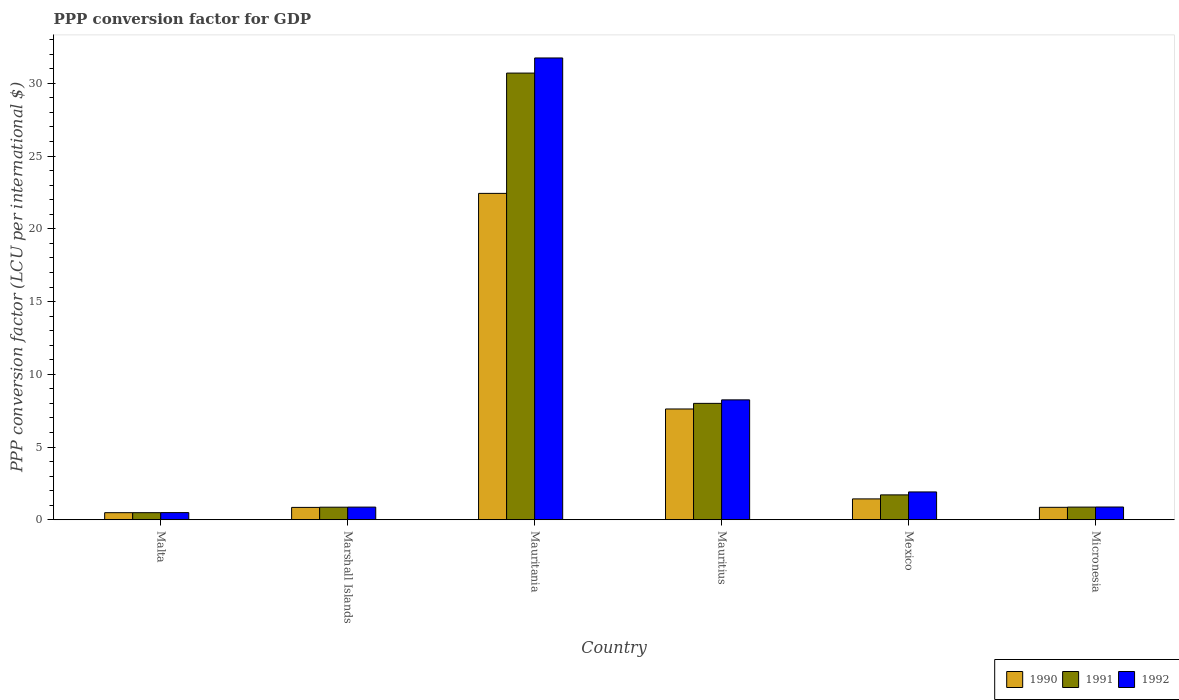How many different coloured bars are there?
Provide a short and direct response. 3. How many bars are there on the 3rd tick from the left?
Make the answer very short. 3. How many bars are there on the 5th tick from the right?
Your answer should be compact. 3. What is the label of the 4th group of bars from the left?
Your answer should be very brief. Mauritius. What is the PPP conversion factor for GDP in 1990 in Marshall Islands?
Make the answer very short. 0.85. Across all countries, what is the maximum PPP conversion factor for GDP in 1990?
Make the answer very short. 22.44. Across all countries, what is the minimum PPP conversion factor for GDP in 1992?
Your answer should be compact. 0.49. In which country was the PPP conversion factor for GDP in 1992 maximum?
Provide a short and direct response. Mauritania. In which country was the PPP conversion factor for GDP in 1990 minimum?
Provide a short and direct response. Malta. What is the total PPP conversion factor for GDP in 1990 in the graph?
Provide a succinct answer. 33.68. What is the difference between the PPP conversion factor for GDP in 1991 in Marshall Islands and that in Micronesia?
Your answer should be compact. -0.01. What is the difference between the PPP conversion factor for GDP in 1992 in Malta and the PPP conversion factor for GDP in 1990 in Marshall Islands?
Ensure brevity in your answer.  -0.36. What is the average PPP conversion factor for GDP in 1990 per country?
Your response must be concise. 5.61. What is the difference between the PPP conversion factor for GDP of/in 1991 and PPP conversion factor for GDP of/in 1990 in Mauritania?
Keep it short and to the point. 8.27. In how many countries, is the PPP conversion factor for GDP in 1991 greater than 6 LCU?
Your response must be concise. 2. What is the ratio of the PPP conversion factor for GDP in 1990 in Malta to that in Marshall Islands?
Your answer should be very brief. 0.57. Is the difference between the PPP conversion factor for GDP in 1991 in Malta and Marshall Islands greater than the difference between the PPP conversion factor for GDP in 1990 in Malta and Marshall Islands?
Offer a very short reply. No. What is the difference between the highest and the second highest PPP conversion factor for GDP in 1992?
Your answer should be compact. 6.33. What is the difference between the highest and the lowest PPP conversion factor for GDP in 1992?
Your response must be concise. 31.25. In how many countries, is the PPP conversion factor for GDP in 1991 greater than the average PPP conversion factor for GDP in 1991 taken over all countries?
Offer a terse response. 2. Is the sum of the PPP conversion factor for GDP in 1990 in Mexico and Micronesia greater than the maximum PPP conversion factor for GDP in 1991 across all countries?
Provide a succinct answer. No. What is the difference between two consecutive major ticks on the Y-axis?
Your answer should be compact. 5. Does the graph contain any zero values?
Ensure brevity in your answer.  No. How many legend labels are there?
Offer a terse response. 3. How are the legend labels stacked?
Your answer should be very brief. Horizontal. What is the title of the graph?
Provide a succinct answer. PPP conversion factor for GDP. Does "1994" appear as one of the legend labels in the graph?
Your answer should be compact. No. What is the label or title of the X-axis?
Provide a succinct answer. Country. What is the label or title of the Y-axis?
Keep it short and to the point. PPP conversion factor (LCU per international $). What is the PPP conversion factor (LCU per international $) of 1990 in Malta?
Provide a short and direct response. 0.49. What is the PPP conversion factor (LCU per international $) in 1991 in Malta?
Ensure brevity in your answer.  0.49. What is the PPP conversion factor (LCU per international $) in 1992 in Malta?
Make the answer very short. 0.49. What is the PPP conversion factor (LCU per international $) of 1990 in Marshall Islands?
Your answer should be compact. 0.85. What is the PPP conversion factor (LCU per international $) in 1991 in Marshall Islands?
Your response must be concise. 0.86. What is the PPP conversion factor (LCU per international $) of 1992 in Marshall Islands?
Offer a very short reply. 0.87. What is the PPP conversion factor (LCU per international $) of 1990 in Mauritania?
Keep it short and to the point. 22.44. What is the PPP conversion factor (LCU per international $) in 1991 in Mauritania?
Offer a terse response. 30.71. What is the PPP conversion factor (LCU per international $) of 1992 in Mauritania?
Provide a short and direct response. 31.75. What is the PPP conversion factor (LCU per international $) in 1990 in Mauritius?
Your answer should be compact. 7.62. What is the PPP conversion factor (LCU per international $) in 1991 in Mauritius?
Offer a very short reply. 8. What is the PPP conversion factor (LCU per international $) of 1992 in Mauritius?
Give a very brief answer. 8.24. What is the PPP conversion factor (LCU per international $) in 1990 in Mexico?
Your response must be concise. 1.43. What is the PPP conversion factor (LCU per international $) in 1991 in Mexico?
Your answer should be compact. 1.71. What is the PPP conversion factor (LCU per international $) of 1992 in Mexico?
Keep it short and to the point. 1.91. What is the PPP conversion factor (LCU per international $) of 1990 in Micronesia?
Provide a short and direct response. 0.86. What is the PPP conversion factor (LCU per international $) in 1991 in Micronesia?
Make the answer very short. 0.87. What is the PPP conversion factor (LCU per international $) of 1992 in Micronesia?
Your answer should be very brief. 0.88. Across all countries, what is the maximum PPP conversion factor (LCU per international $) of 1990?
Offer a terse response. 22.44. Across all countries, what is the maximum PPP conversion factor (LCU per international $) of 1991?
Provide a short and direct response. 30.71. Across all countries, what is the maximum PPP conversion factor (LCU per international $) in 1992?
Your response must be concise. 31.75. Across all countries, what is the minimum PPP conversion factor (LCU per international $) in 1990?
Provide a succinct answer. 0.49. Across all countries, what is the minimum PPP conversion factor (LCU per international $) in 1991?
Offer a very short reply. 0.49. Across all countries, what is the minimum PPP conversion factor (LCU per international $) in 1992?
Make the answer very short. 0.49. What is the total PPP conversion factor (LCU per international $) in 1990 in the graph?
Your response must be concise. 33.68. What is the total PPP conversion factor (LCU per international $) in 1991 in the graph?
Give a very brief answer. 42.64. What is the total PPP conversion factor (LCU per international $) of 1992 in the graph?
Your answer should be compact. 44.14. What is the difference between the PPP conversion factor (LCU per international $) of 1990 in Malta and that in Marshall Islands?
Provide a short and direct response. -0.36. What is the difference between the PPP conversion factor (LCU per international $) of 1991 in Malta and that in Marshall Islands?
Your response must be concise. -0.38. What is the difference between the PPP conversion factor (LCU per international $) of 1992 in Malta and that in Marshall Islands?
Offer a very short reply. -0.38. What is the difference between the PPP conversion factor (LCU per international $) in 1990 in Malta and that in Mauritania?
Your answer should be very brief. -21.95. What is the difference between the PPP conversion factor (LCU per international $) in 1991 in Malta and that in Mauritania?
Your response must be concise. -30.22. What is the difference between the PPP conversion factor (LCU per international $) of 1992 in Malta and that in Mauritania?
Keep it short and to the point. -31.25. What is the difference between the PPP conversion factor (LCU per international $) of 1990 in Malta and that in Mauritius?
Keep it short and to the point. -7.13. What is the difference between the PPP conversion factor (LCU per international $) of 1991 in Malta and that in Mauritius?
Your answer should be compact. -7.51. What is the difference between the PPP conversion factor (LCU per international $) in 1992 in Malta and that in Mauritius?
Your answer should be compact. -7.75. What is the difference between the PPP conversion factor (LCU per international $) of 1990 in Malta and that in Mexico?
Provide a short and direct response. -0.95. What is the difference between the PPP conversion factor (LCU per international $) in 1991 in Malta and that in Mexico?
Keep it short and to the point. -1.22. What is the difference between the PPP conversion factor (LCU per international $) in 1992 in Malta and that in Mexico?
Make the answer very short. -1.42. What is the difference between the PPP conversion factor (LCU per international $) in 1990 in Malta and that in Micronesia?
Make the answer very short. -0.37. What is the difference between the PPP conversion factor (LCU per international $) in 1991 in Malta and that in Micronesia?
Your answer should be very brief. -0.38. What is the difference between the PPP conversion factor (LCU per international $) in 1992 in Malta and that in Micronesia?
Offer a terse response. -0.38. What is the difference between the PPP conversion factor (LCU per international $) in 1990 in Marshall Islands and that in Mauritania?
Ensure brevity in your answer.  -21.59. What is the difference between the PPP conversion factor (LCU per international $) of 1991 in Marshall Islands and that in Mauritania?
Keep it short and to the point. -29.84. What is the difference between the PPP conversion factor (LCU per international $) in 1992 in Marshall Islands and that in Mauritania?
Your response must be concise. -30.88. What is the difference between the PPP conversion factor (LCU per international $) in 1990 in Marshall Islands and that in Mauritius?
Offer a terse response. -6.77. What is the difference between the PPP conversion factor (LCU per international $) in 1991 in Marshall Islands and that in Mauritius?
Offer a very short reply. -7.14. What is the difference between the PPP conversion factor (LCU per international $) of 1992 in Marshall Islands and that in Mauritius?
Offer a terse response. -7.37. What is the difference between the PPP conversion factor (LCU per international $) of 1990 in Marshall Islands and that in Mexico?
Provide a succinct answer. -0.58. What is the difference between the PPP conversion factor (LCU per international $) of 1991 in Marshall Islands and that in Mexico?
Your answer should be compact. -0.85. What is the difference between the PPP conversion factor (LCU per international $) in 1992 in Marshall Islands and that in Mexico?
Provide a succinct answer. -1.04. What is the difference between the PPP conversion factor (LCU per international $) in 1990 in Marshall Islands and that in Micronesia?
Your answer should be compact. -0.01. What is the difference between the PPP conversion factor (LCU per international $) of 1991 in Marshall Islands and that in Micronesia?
Keep it short and to the point. -0.01. What is the difference between the PPP conversion factor (LCU per international $) in 1992 in Marshall Islands and that in Micronesia?
Make the answer very short. -0.01. What is the difference between the PPP conversion factor (LCU per international $) of 1990 in Mauritania and that in Mauritius?
Make the answer very short. 14.82. What is the difference between the PPP conversion factor (LCU per international $) of 1991 in Mauritania and that in Mauritius?
Your response must be concise. 22.7. What is the difference between the PPP conversion factor (LCU per international $) of 1992 in Mauritania and that in Mauritius?
Give a very brief answer. 23.5. What is the difference between the PPP conversion factor (LCU per international $) of 1990 in Mauritania and that in Mexico?
Keep it short and to the point. 21. What is the difference between the PPP conversion factor (LCU per international $) in 1991 in Mauritania and that in Mexico?
Your response must be concise. 29. What is the difference between the PPP conversion factor (LCU per international $) in 1992 in Mauritania and that in Mexico?
Offer a very short reply. 29.83. What is the difference between the PPP conversion factor (LCU per international $) in 1990 in Mauritania and that in Micronesia?
Make the answer very short. 21.58. What is the difference between the PPP conversion factor (LCU per international $) of 1991 in Mauritania and that in Micronesia?
Give a very brief answer. 29.84. What is the difference between the PPP conversion factor (LCU per international $) in 1992 in Mauritania and that in Micronesia?
Make the answer very short. 30.87. What is the difference between the PPP conversion factor (LCU per international $) of 1990 in Mauritius and that in Mexico?
Your response must be concise. 6.18. What is the difference between the PPP conversion factor (LCU per international $) of 1991 in Mauritius and that in Mexico?
Provide a short and direct response. 6.29. What is the difference between the PPP conversion factor (LCU per international $) of 1992 in Mauritius and that in Mexico?
Give a very brief answer. 6.33. What is the difference between the PPP conversion factor (LCU per international $) in 1990 in Mauritius and that in Micronesia?
Your response must be concise. 6.76. What is the difference between the PPP conversion factor (LCU per international $) of 1991 in Mauritius and that in Micronesia?
Offer a very short reply. 7.13. What is the difference between the PPP conversion factor (LCU per international $) in 1992 in Mauritius and that in Micronesia?
Give a very brief answer. 7.37. What is the difference between the PPP conversion factor (LCU per international $) in 1990 in Mexico and that in Micronesia?
Ensure brevity in your answer.  0.58. What is the difference between the PPP conversion factor (LCU per international $) in 1991 in Mexico and that in Micronesia?
Provide a succinct answer. 0.84. What is the difference between the PPP conversion factor (LCU per international $) in 1992 in Mexico and that in Micronesia?
Offer a very short reply. 1.04. What is the difference between the PPP conversion factor (LCU per international $) in 1990 in Malta and the PPP conversion factor (LCU per international $) in 1991 in Marshall Islands?
Ensure brevity in your answer.  -0.38. What is the difference between the PPP conversion factor (LCU per international $) of 1990 in Malta and the PPP conversion factor (LCU per international $) of 1992 in Marshall Islands?
Ensure brevity in your answer.  -0.38. What is the difference between the PPP conversion factor (LCU per international $) in 1991 in Malta and the PPP conversion factor (LCU per international $) in 1992 in Marshall Islands?
Give a very brief answer. -0.38. What is the difference between the PPP conversion factor (LCU per international $) in 1990 in Malta and the PPP conversion factor (LCU per international $) in 1991 in Mauritania?
Your answer should be compact. -30.22. What is the difference between the PPP conversion factor (LCU per international $) in 1990 in Malta and the PPP conversion factor (LCU per international $) in 1992 in Mauritania?
Provide a succinct answer. -31.26. What is the difference between the PPP conversion factor (LCU per international $) in 1991 in Malta and the PPP conversion factor (LCU per international $) in 1992 in Mauritania?
Keep it short and to the point. -31.26. What is the difference between the PPP conversion factor (LCU per international $) of 1990 in Malta and the PPP conversion factor (LCU per international $) of 1991 in Mauritius?
Provide a short and direct response. -7.51. What is the difference between the PPP conversion factor (LCU per international $) of 1990 in Malta and the PPP conversion factor (LCU per international $) of 1992 in Mauritius?
Provide a succinct answer. -7.76. What is the difference between the PPP conversion factor (LCU per international $) of 1991 in Malta and the PPP conversion factor (LCU per international $) of 1992 in Mauritius?
Provide a short and direct response. -7.76. What is the difference between the PPP conversion factor (LCU per international $) in 1990 in Malta and the PPP conversion factor (LCU per international $) in 1991 in Mexico?
Make the answer very short. -1.22. What is the difference between the PPP conversion factor (LCU per international $) of 1990 in Malta and the PPP conversion factor (LCU per international $) of 1992 in Mexico?
Ensure brevity in your answer.  -1.43. What is the difference between the PPP conversion factor (LCU per international $) of 1991 in Malta and the PPP conversion factor (LCU per international $) of 1992 in Mexico?
Provide a short and direct response. -1.43. What is the difference between the PPP conversion factor (LCU per international $) of 1990 in Malta and the PPP conversion factor (LCU per international $) of 1991 in Micronesia?
Your answer should be compact. -0.38. What is the difference between the PPP conversion factor (LCU per international $) of 1990 in Malta and the PPP conversion factor (LCU per international $) of 1992 in Micronesia?
Offer a terse response. -0.39. What is the difference between the PPP conversion factor (LCU per international $) in 1991 in Malta and the PPP conversion factor (LCU per international $) in 1992 in Micronesia?
Your answer should be compact. -0.39. What is the difference between the PPP conversion factor (LCU per international $) of 1990 in Marshall Islands and the PPP conversion factor (LCU per international $) of 1991 in Mauritania?
Give a very brief answer. -29.86. What is the difference between the PPP conversion factor (LCU per international $) in 1990 in Marshall Islands and the PPP conversion factor (LCU per international $) in 1992 in Mauritania?
Your response must be concise. -30.9. What is the difference between the PPP conversion factor (LCU per international $) of 1991 in Marshall Islands and the PPP conversion factor (LCU per international $) of 1992 in Mauritania?
Provide a short and direct response. -30.88. What is the difference between the PPP conversion factor (LCU per international $) in 1990 in Marshall Islands and the PPP conversion factor (LCU per international $) in 1991 in Mauritius?
Your answer should be very brief. -7.15. What is the difference between the PPP conversion factor (LCU per international $) in 1990 in Marshall Islands and the PPP conversion factor (LCU per international $) in 1992 in Mauritius?
Your answer should be compact. -7.39. What is the difference between the PPP conversion factor (LCU per international $) of 1991 in Marshall Islands and the PPP conversion factor (LCU per international $) of 1992 in Mauritius?
Provide a short and direct response. -7.38. What is the difference between the PPP conversion factor (LCU per international $) in 1990 in Marshall Islands and the PPP conversion factor (LCU per international $) in 1991 in Mexico?
Your answer should be very brief. -0.86. What is the difference between the PPP conversion factor (LCU per international $) of 1990 in Marshall Islands and the PPP conversion factor (LCU per international $) of 1992 in Mexico?
Your answer should be very brief. -1.06. What is the difference between the PPP conversion factor (LCU per international $) of 1991 in Marshall Islands and the PPP conversion factor (LCU per international $) of 1992 in Mexico?
Your response must be concise. -1.05. What is the difference between the PPP conversion factor (LCU per international $) in 1990 in Marshall Islands and the PPP conversion factor (LCU per international $) in 1991 in Micronesia?
Your answer should be very brief. -0.02. What is the difference between the PPP conversion factor (LCU per international $) of 1990 in Marshall Islands and the PPP conversion factor (LCU per international $) of 1992 in Micronesia?
Your answer should be very brief. -0.03. What is the difference between the PPP conversion factor (LCU per international $) of 1991 in Marshall Islands and the PPP conversion factor (LCU per international $) of 1992 in Micronesia?
Keep it short and to the point. -0.01. What is the difference between the PPP conversion factor (LCU per international $) of 1990 in Mauritania and the PPP conversion factor (LCU per international $) of 1991 in Mauritius?
Provide a succinct answer. 14.44. What is the difference between the PPP conversion factor (LCU per international $) of 1990 in Mauritania and the PPP conversion factor (LCU per international $) of 1992 in Mauritius?
Offer a terse response. 14.19. What is the difference between the PPP conversion factor (LCU per international $) in 1991 in Mauritania and the PPP conversion factor (LCU per international $) in 1992 in Mauritius?
Offer a terse response. 22.46. What is the difference between the PPP conversion factor (LCU per international $) in 1990 in Mauritania and the PPP conversion factor (LCU per international $) in 1991 in Mexico?
Offer a very short reply. 20.73. What is the difference between the PPP conversion factor (LCU per international $) in 1990 in Mauritania and the PPP conversion factor (LCU per international $) in 1992 in Mexico?
Provide a short and direct response. 20.52. What is the difference between the PPP conversion factor (LCU per international $) in 1991 in Mauritania and the PPP conversion factor (LCU per international $) in 1992 in Mexico?
Provide a succinct answer. 28.79. What is the difference between the PPP conversion factor (LCU per international $) of 1990 in Mauritania and the PPP conversion factor (LCU per international $) of 1991 in Micronesia?
Ensure brevity in your answer.  21.57. What is the difference between the PPP conversion factor (LCU per international $) of 1990 in Mauritania and the PPP conversion factor (LCU per international $) of 1992 in Micronesia?
Offer a terse response. 21.56. What is the difference between the PPP conversion factor (LCU per international $) in 1991 in Mauritania and the PPP conversion factor (LCU per international $) in 1992 in Micronesia?
Offer a terse response. 29.83. What is the difference between the PPP conversion factor (LCU per international $) in 1990 in Mauritius and the PPP conversion factor (LCU per international $) in 1991 in Mexico?
Ensure brevity in your answer.  5.91. What is the difference between the PPP conversion factor (LCU per international $) of 1990 in Mauritius and the PPP conversion factor (LCU per international $) of 1992 in Mexico?
Offer a terse response. 5.7. What is the difference between the PPP conversion factor (LCU per international $) of 1991 in Mauritius and the PPP conversion factor (LCU per international $) of 1992 in Mexico?
Offer a terse response. 6.09. What is the difference between the PPP conversion factor (LCU per international $) of 1990 in Mauritius and the PPP conversion factor (LCU per international $) of 1991 in Micronesia?
Provide a succinct answer. 6.75. What is the difference between the PPP conversion factor (LCU per international $) of 1990 in Mauritius and the PPP conversion factor (LCU per international $) of 1992 in Micronesia?
Offer a very short reply. 6.74. What is the difference between the PPP conversion factor (LCU per international $) in 1991 in Mauritius and the PPP conversion factor (LCU per international $) in 1992 in Micronesia?
Provide a succinct answer. 7.12. What is the difference between the PPP conversion factor (LCU per international $) in 1990 in Mexico and the PPP conversion factor (LCU per international $) in 1991 in Micronesia?
Make the answer very short. 0.56. What is the difference between the PPP conversion factor (LCU per international $) in 1990 in Mexico and the PPP conversion factor (LCU per international $) in 1992 in Micronesia?
Your answer should be compact. 0.56. What is the difference between the PPP conversion factor (LCU per international $) of 1991 in Mexico and the PPP conversion factor (LCU per international $) of 1992 in Micronesia?
Provide a succinct answer. 0.83. What is the average PPP conversion factor (LCU per international $) of 1990 per country?
Your response must be concise. 5.61. What is the average PPP conversion factor (LCU per international $) of 1991 per country?
Keep it short and to the point. 7.11. What is the average PPP conversion factor (LCU per international $) in 1992 per country?
Give a very brief answer. 7.36. What is the difference between the PPP conversion factor (LCU per international $) in 1990 and PPP conversion factor (LCU per international $) in 1991 in Malta?
Offer a very short reply. -0. What is the difference between the PPP conversion factor (LCU per international $) in 1990 and PPP conversion factor (LCU per international $) in 1992 in Malta?
Keep it short and to the point. -0.01. What is the difference between the PPP conversion factor (LCU per international $) in 1991 and PPP conversion factor (LCU per international $) in 1992 in Malta?
Your answer should be compact. -0.01. What is the difference between the PPP conversion factor (LCU per international $) of 1990 and PPP conversion factor (LCU per international $) of 1991 in Marshall Islands?
Make the answer very short. -0.01. What is the difference between the PPP conversion factor (LCU per international $) in 1990 and PPP conversion factor (LCU per international $) in 1992 in Marshall Islands?
Keep it short and to the point. -0.02. What is the difference between the PPP conversion factor (LCU per international $) of 1991 and PPP conversion factor (LCU per international $) of 1992 in Marshall Islands?
Offer a terse response. -0.01. What is the difference between the PPP conversion factor (LCU per international $) in 1990 and PPP conversion factor (LCU per international $) in 1991 in Mauritania?
Give a very brief answer. -8.27. What is the difference between the PPP conversion factor (LCU per international $) in 1990 and PPP conversion factor (LCU per international $) in 1992 in Mauritania?
Give a very brief answer. -9.31. What is the difference between the PPP conversion factor (LCU per international $) in 1991 and PPP conversion factor (LCU per international $) in 1992 in Mauritania?
Ensure brevity in your answer.  -1.04. What is the difference between the PPP conversion factor (LCU per international $) in 1990 and PPP conversion factor (LCU per international $) in 1991 in Mauritius?
Your answer should be compact. -0.39. What is the difference between the PPP conversion factor (LCU per international $) in 1990 and PPP conversion factor (LCU per international $) in 1992 in Mauritius?
Your response must be concise. -0.63. What is the difference between the PPP conversion factor (LCU per international $) of 1991 and PPP conversion factor (LCU per international $) of 1992 in Mauritius?
Offer a very short reply. -0.24. What is the difference between the PPP conversion factor (LCU per international $) of 1990 and PPP conversion factor (LCU per international $) of 1991 in Mexico?
Provide a succinct answer. -0.28. What is the difference between the PPP conversion factor (LCU per international $) of 1990 and PPP conversion factor (LCU per international $) of 1992 in Mexico?
Keep it short and to the point. -0.48. What is the difference between the PPP conversion factor (LCU per international $) of 1991 and PPP conversion factor (LCU per international $) of 1992 in Mexico?
Provide a short and direct response. -0.2. What is the difference between the PPP conversion factor (LCU per international $) in 1990 and PPP conversion factor (LCU per international $) in 1991 in Micronesia?
Provide a succinct answer. -0.01. What is the difference between the PPP conversion factor (LCU per international $) in 1990 and PPP conversion factor (LCU per international $) in 1992 in Micronesia?
Keep it short and to the point. -0.02. What is the difference between the PPP conversion factor (LCU per international $) of 1991 and PPP conversion factor (LCU per international $) of 1992 in Micronesia?
Give a very brief answer. -0.01. What is the ratio of the PPP conversion factor (LCU per international $) of 1990 in Malta to that in Marshall Islands?
Offer a very short reply. 0.57. What is the ratio of the PPP conversion factor (LCU per international $) in 1991 in Malta to that in Marshall Islands?
Provide a succinct answer. 0.56. What is the ratio of the PPP conversion factor (LCU per international $) in 1992 in Malta to that in Marshall Islands?
Ensure brevity in your answer.  0.57. What is the ratio of the PPP conversion factor (LCU per international $) of 1990 in Malta to that in Mauritania?
Make the answer very short. 0.02. What is the ratio of the PPP conversion factor (LCU per international $) of 1991 in Malta to that in Mauritania?
Give a very brief answer. 0.02. What is the ratio of the PPP conversion factor (LCU per international $) in 1992 in Malta to that in Mauritania?
Ensure brevity in your answer.  0.02. What is the ratio of the PPP conversion factor (LCU per international $) in 1990 in Malta to that in Mauritius?
Keep it short and to the point. 0.06. What is the ratio of the PPP conversion factor (LCU per international $) of 1991 in Malta to that in Mauritius?
Keep it short and to the point. 0.06. What is the ratio of the PPP conversion factor (LCU per international $) of 1992 in Malta to that in Mauritius?
Your answer should be very brief. 0.06. What is the ratio of the PPP conversion factor (LCU per international $) of 1990 in Malta to that in Mexico?
Your answer should be compact. 0.34. What is the ratio of the PPP conversion factor (LCU per international $) of 1991 in Malta to that in Mexico?
Provide a short and direct response. 0.28. What is the ratio of the PPP conversion factor (LCU per international $) of 1992 in Malta to that in Mexico?
Make the answer very short. 0.26. What is the ratio of the PPP conversion factor (LCU per international $) of 1990 in Malta to that in Micronesia?
Provide a short and direct response. 0.57. What is the ratio of the PPP conversion factor (LCU per international $) of 1991 in Malta to that in Micronesia?
Your answer should be compact. 0.56. What is the ratio of the PPP conversion factor (LCU per international $) of 1992 in Malta to that in Micronesia?
Offer a terse response. 0.56. What is the ratio of the PPP conversion factor (LCU per international $) of 1990 in Marshall Islands to that in Mauritania?
Offer a terse response. 0.04. What is the ratio of the PPP conversion factor (LCU per international $) in 1991 in Marshall Islands to that in Mauritania?
Offer a terse response. 0.03. What is the ratio of the PPP conversion factor (LCU per international $) of 1992 in Marshall Islands to that in Mauritania?
Your answer should be very brief. 0.03. What is the ratio of the PPP conversion factor (LCU per international $) in 1990 in Marshall Islands to that in Mauritius?
Your answer should be compact. 0.11. What is the ratio of the PPP conversion factor (LCU per international $) in 1991 in Marshall Islands to that in Mauritius?
Your answer should be very brief. 0.11. What is the ratio of the PPP conversion factor (LCU per international $) in 1992 in Marshall Islands to that in Mauritius?
Keep it short and to the point. 0.11. What is the ratio of the PPP conversion factor (LCU per international $) in 1990 in Marshall Islands to that in Mexico?
Provide a succinct answer. 0.59. What is the ratio of the PPP conversion factor (LCU per international $) in 1991 in Marshall Islands to that in Mexico?
Give a very brief answer. 0.51. What is the ratio of the PPP conversion factor (LCU per international $) of 1992 in Marshall Islands to that in Mexico?
Offer a terse response. 0.45. What is the ratio of the PPP conversion factor (LCU per international $) of 1992 in Marshall Islands to that in Micronesia?
Give a very brief answer. 0.99. What is the ratio of the PPP conversion factor (LCU per international $) of 1990 in Mauritania to that in Mauritius?
Provide a succinct answer. 2.95. What is the ratio of the PPP conversion factor (LCU per international $) in 1991 in Mauritania to that in Mauritius?
Your answer should be very brief. 3.84. What is the ratio of the PPP conversion factor (LCU per international $) of 1992 in Mauritania to that in Mauritius?
Provide a succinct answer. 3.85. What is the ratio of the PPP conversion factor (LCU per international $) in 1990 in Mauritania to that in Mexico?
Give a very brief answer. 15.65. What is the ratio of the PPP conversion factor (LCU per international $) in 1991 in Mauritania to that in Mexico?
Keep it short and to the point. 17.95. What is the ratio of the PPP conversion factor (LCU per international $) of 1992 in Mauritania to that in Mexico?
Make the answer very short. 16.59. What is the ratio of the PPP conversion factor (LCU per international $) of 1990 in Mauritania to that in Micronesia?
Keep it short and to the point. 26.22. What is the ratio of the PPP conversion factor (LCU per international $) in 1991 in Mauritania to that in Micronesia?
Offer a terse response. 35.28. What is the ratio of the PPP conversion factor (LCU per international $) of 1992 in Mauritania to that in Micronesia?
Your answer should be compact. 36.21. What is the ratio of the PPP conversion factor (LCU per international $) of 1990 in Mauritius to that in Mexico?
Offer a terse response. 5.31. What is the ratio of the PPP conversion factor (LCU per international $) in 1991 in Mauritius to that in Mexico?
Offer a very short reply. 4.68. What is the ratio of the PPP conversion factor (LCU per international $) of 1992 in Mauritius to that in Mexico?
Your answer should be very brief. 4.31. What is the ratio of the PPP conversion factor (LCU per international $) of 1990 in Mauritius to that in Micronesia?
Ensure brevity in your answer.  8.9. What is the ratio of the PPP conversion factor (LCU per international $) of 1991 in Mauritius to that in Micronesia?
Your answer should be very brief. 9.19. What is the ratio of the PPP conversion factor (LCU per international $) of 1992 in Mauritius to that in Micronesia?
Your answer should be very brief. 9.4. What is the ratio of the PPP conversion factor (LCU per international $) of 1990 in Mexico to that in Micronesia?
Ensure brevity in your answer.  1.68. What is the ratio of the PPP conversion factor (LCU per international $) of 1991 in Mexico to that in Micronesia?
Your response must be concise. 1.97. What is the ratio of the PPP conversion factor (LCU per international $) of 1992 in Mexico to that in Micronesia?
Offer a very short reply. 2.18. What is the difference between the highest and the second highest PPP conversion factor (LCU per international $) in 1990?
Offer a very short reply. 14.82. What is the difference between the highest and the second highest PPP conversion factor (LCU per international $) in 1991?
Give a very brief answer. 22.7. What is the difference between the highest and the second highest PPP conversion factor (LCU per international $) of 1992?
Provide a succinct answer. 23.5. What is the difference between the highest and the lowest PPP conversion factor (LCU per international $) in 1990?
Ensure brevity in your answer.  21.95. What is the difference between the highest and the lowest PPP conversion factor (LCU per international $) of 1991?
Your response must be concise. 30.22. What is the difference between the highest and the lowest PPP conversion factor (LCU per international $) of 1992?
Offer a terse response. 31.25. 